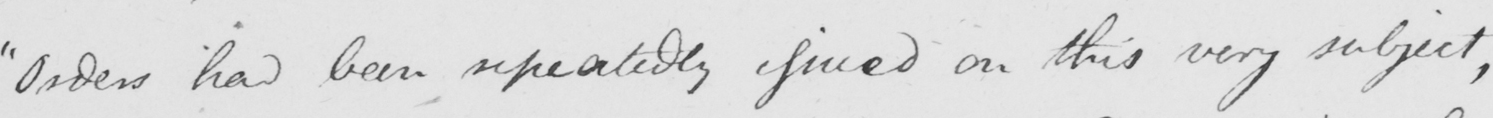What is written in this line of handwriting? Orders had been repeatedly issued on this very subject , 